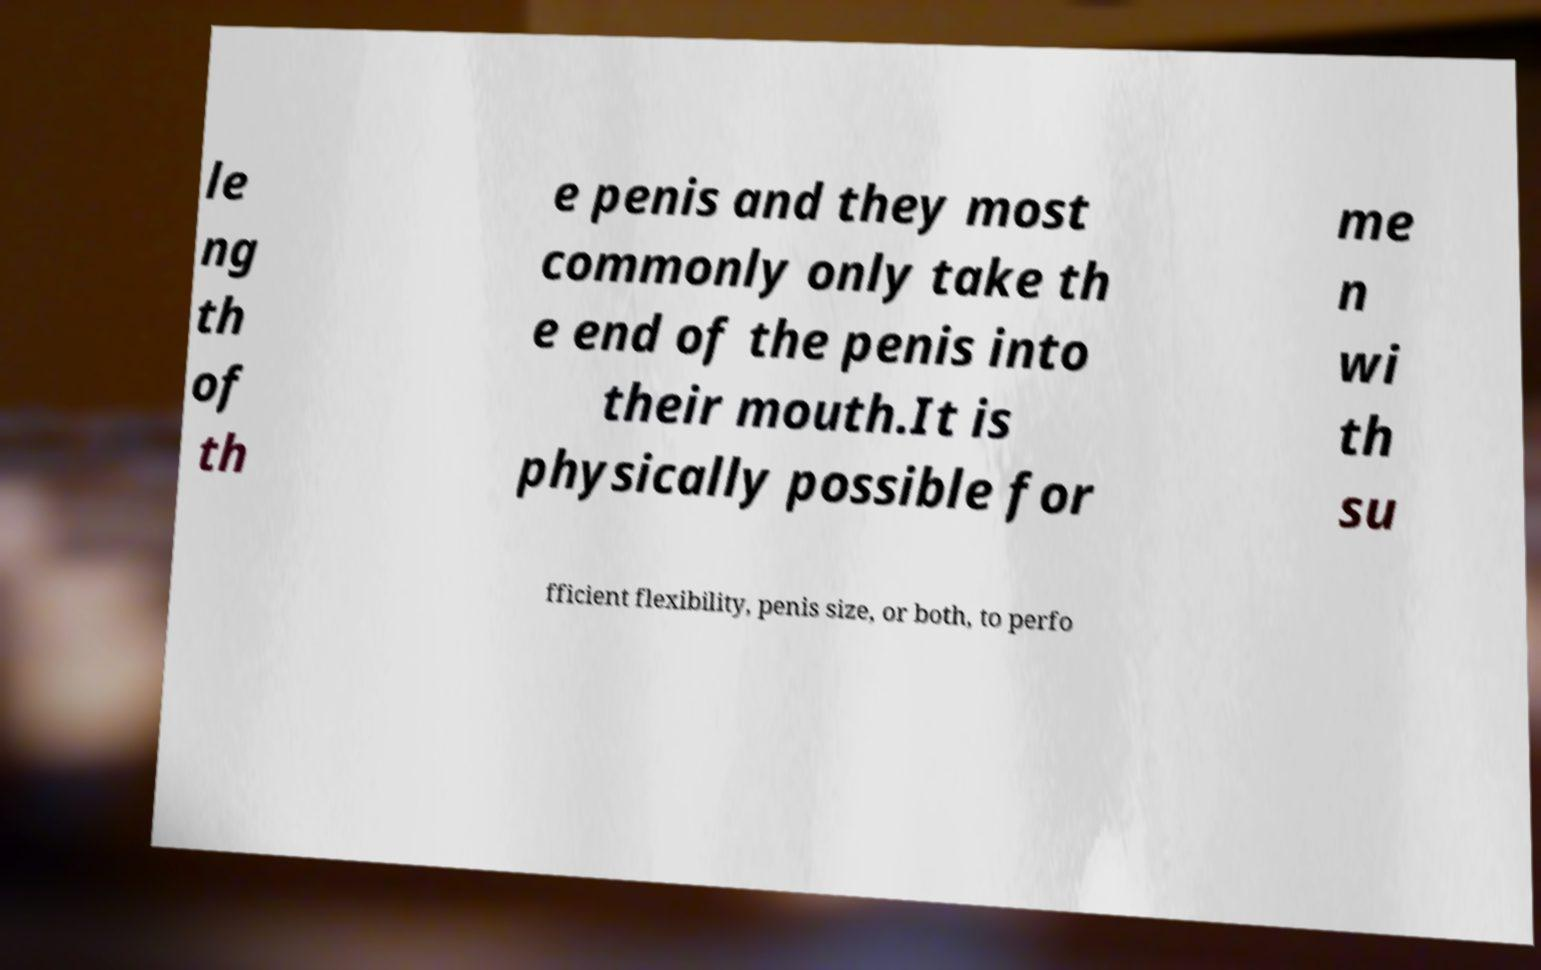What messages or text are displayed in this image? I need them in a readable, typed format. le ng th of th e penis and they most commonly only take th e end of the penis into their mouth.It is physically possible for me n wi th su fficient flexibility, penis size, or both, to perfo 